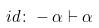<formula> <loc_0><loc_0><loc_500><loc_500>{ i d \colon - \alpha \vdash \alpha }</formula> 